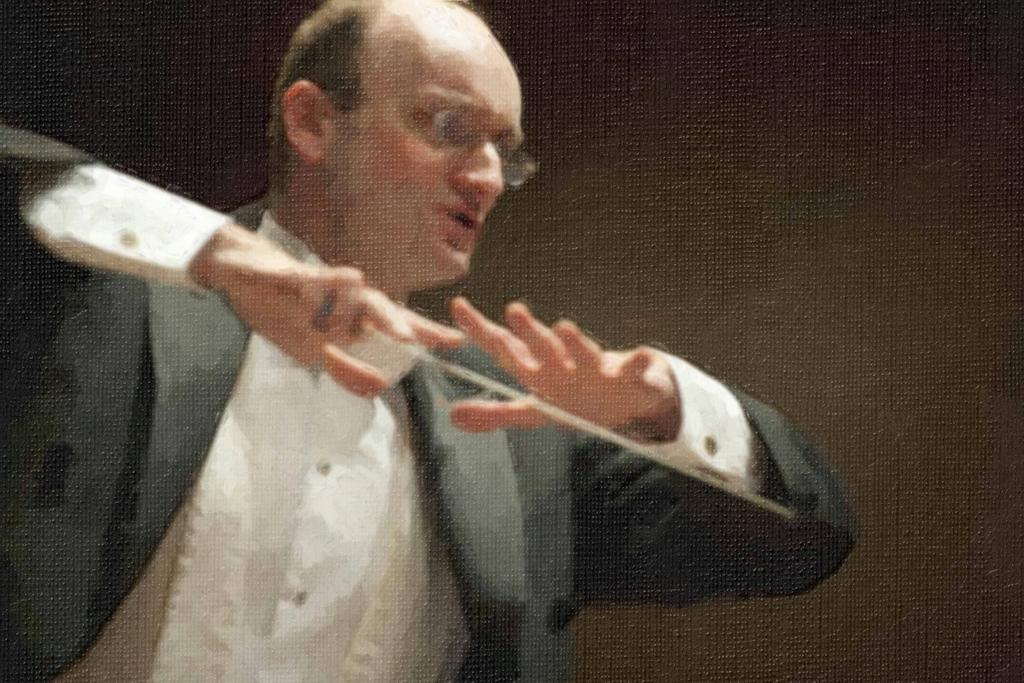Who or what is present in the image? There is a person in the image. What type of clothing is the person wearing? The person is wearing a blazer and a shirt. What is the person holding in the image? The person is holding a stick. What is the color of the background in the image? The background of the image is black. Can you describe the texture of the fairies' wings in the image? There are no fairies present in the image, so their wings' texture cannot be described. 